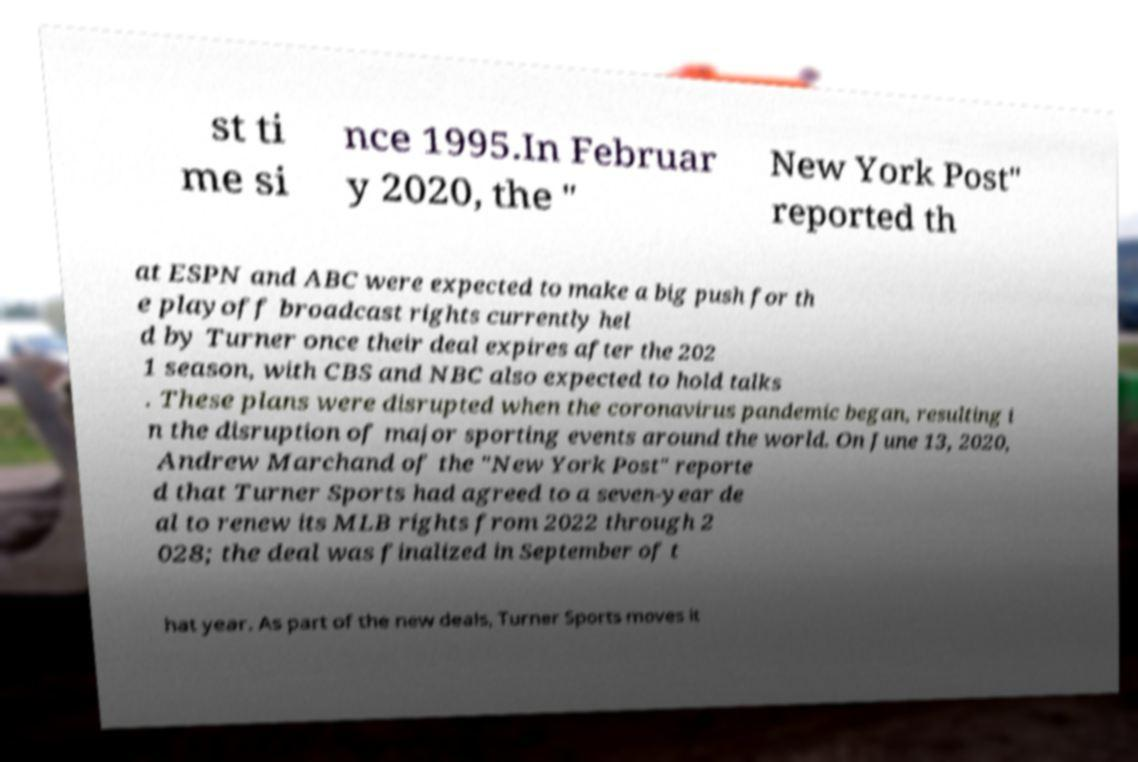What messages or text are displayed in this image? I need them in a readable, typed format. st ti me si nce 1995.In Februar y 2020, the " New York Post" reported th at ESPN and ABC were expected to make a big push for th e playoff broadcast rights currently hel d by Turner once their deal expires after the 202 1 season, with CBS and NBC also expected to hold talks . These plans were disrupted when the coronavirus pandemic began, resulting i n the disruption of major sporting events around the world. On June 13, 2020, Andrew Marchand of the "New York Post" reporte d that Turner Sports had agreed to a seven-year de al to renew its MLB rights from 2022 through 2 028; the deal was finalized in September of t hat year. As part of the new deals, Turner Sports moves it 